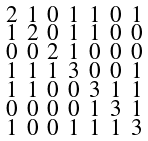<formula> <loc_0><loc_0><loc_500><loc_500>\begin{smallmatrix} 2 & 1 & 0 & 1 & 1 & 0 & 1 \\ 1 & 2 & 0 & 1 & 1 & 0 & 0 \\ 0 & 0 & 2 & 1 & 0 & 0 & 0 \\ 1 & 1 & 1 & 3 & 0 & 0 & 1 \\ 1 & 1 & 0 & 0 & 3 & 1 & 1 \\ 0 & 0 & 0 & 0 & 1 & 3 & 1 \\ 1 & 0 & 0 & 1 & 1 & 1 & 3 \end{smallmatrix}</formula> 